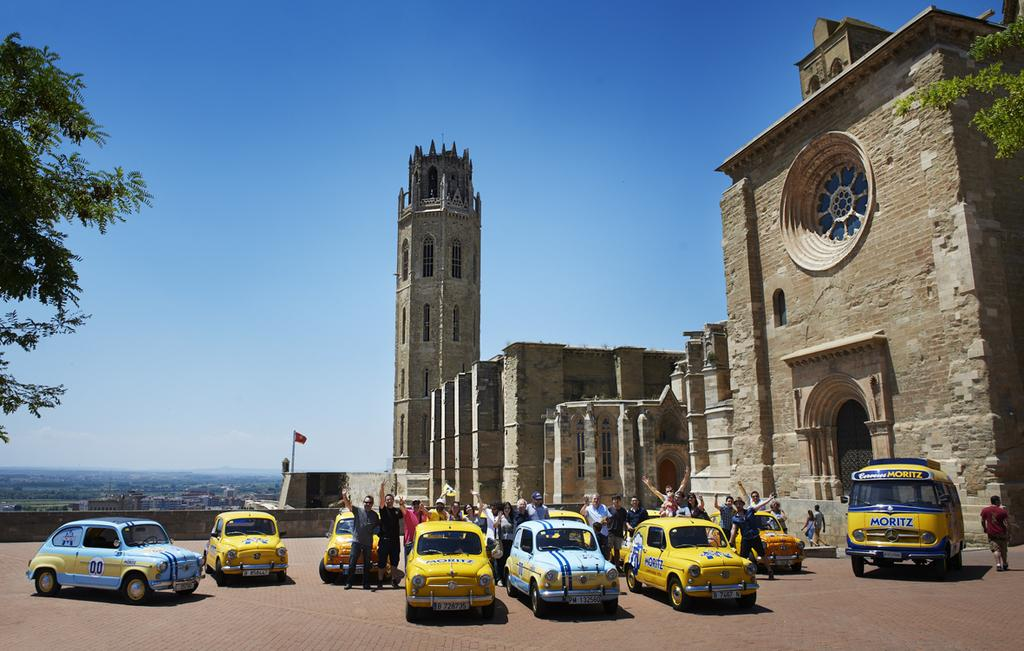Provide a one-sentence caption for the provided image. The company that is written all over the vehicles is Moritz. 